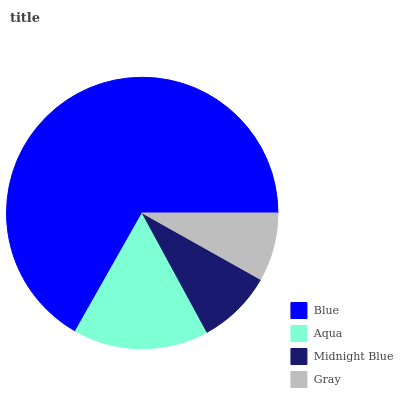Is Gray the minimum?
Answer yes or no. Yes. Is Blue the maximum?
Answer yes or no. Yes. Is Aqua the minimum?
Answer yes or no. No. Is Aqua the maximum?
Answer yes or no. No. Is Blue greater than Aqua?
Answer yes or no. Yes. Is Aqua less than Blue?
Answer yes or no. Yes. Is Aqua greater than Blue?
Answer yes or no. No. Is Blue less than Aqua?
Answer yes or no. No. Is Aqua the high median?
Answer yes or no. Yes. Is Midnight Blue the low median?
Answer yes or no. Yes. Is Midnight Blue the high median?
Answer yes or no. No. Is Aqua the low median?
Answer yes or no. No. 